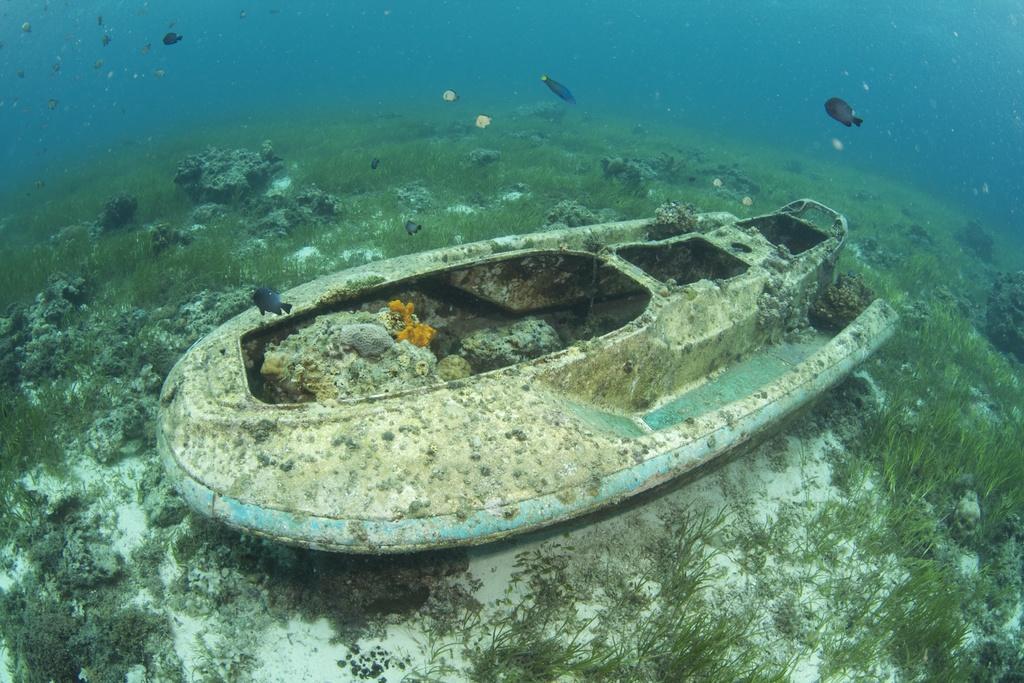How would you summarize this image in a sentence or two? In this image we can see fishes in the water and we can see grass, plants and a boat. 